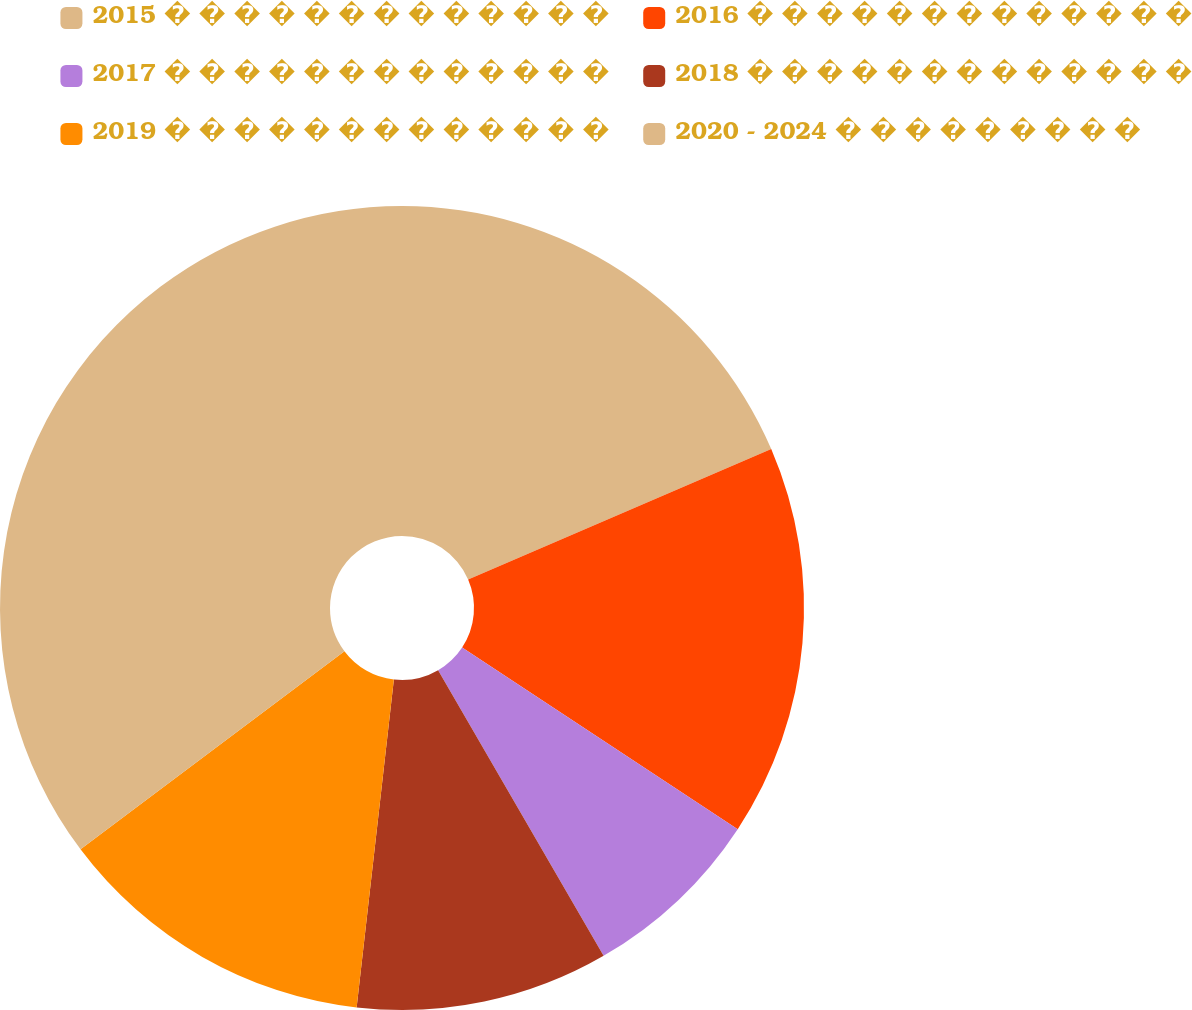Convert chart. <chart><loc_0><loc_0><loc_500><loc_500><pie_chart><fcel>2015 � � � � � � � � � � � � �<fcel>2016 � � � � � � � � � � � � �<fcel>2017 � � � � � � � � � � � � �<fcel>2018 � � � � � � � � � � � � �<fcel>2019 � � � � � � � � � � � � �<fcel>2020 - 2024 � � � � � � � � �<nl><fcel>18.53%<fcel>15.74%<fcel>7.37%<fcel>10.16%<fcel>12.95%<fcel>35.25%<nl></chart> 